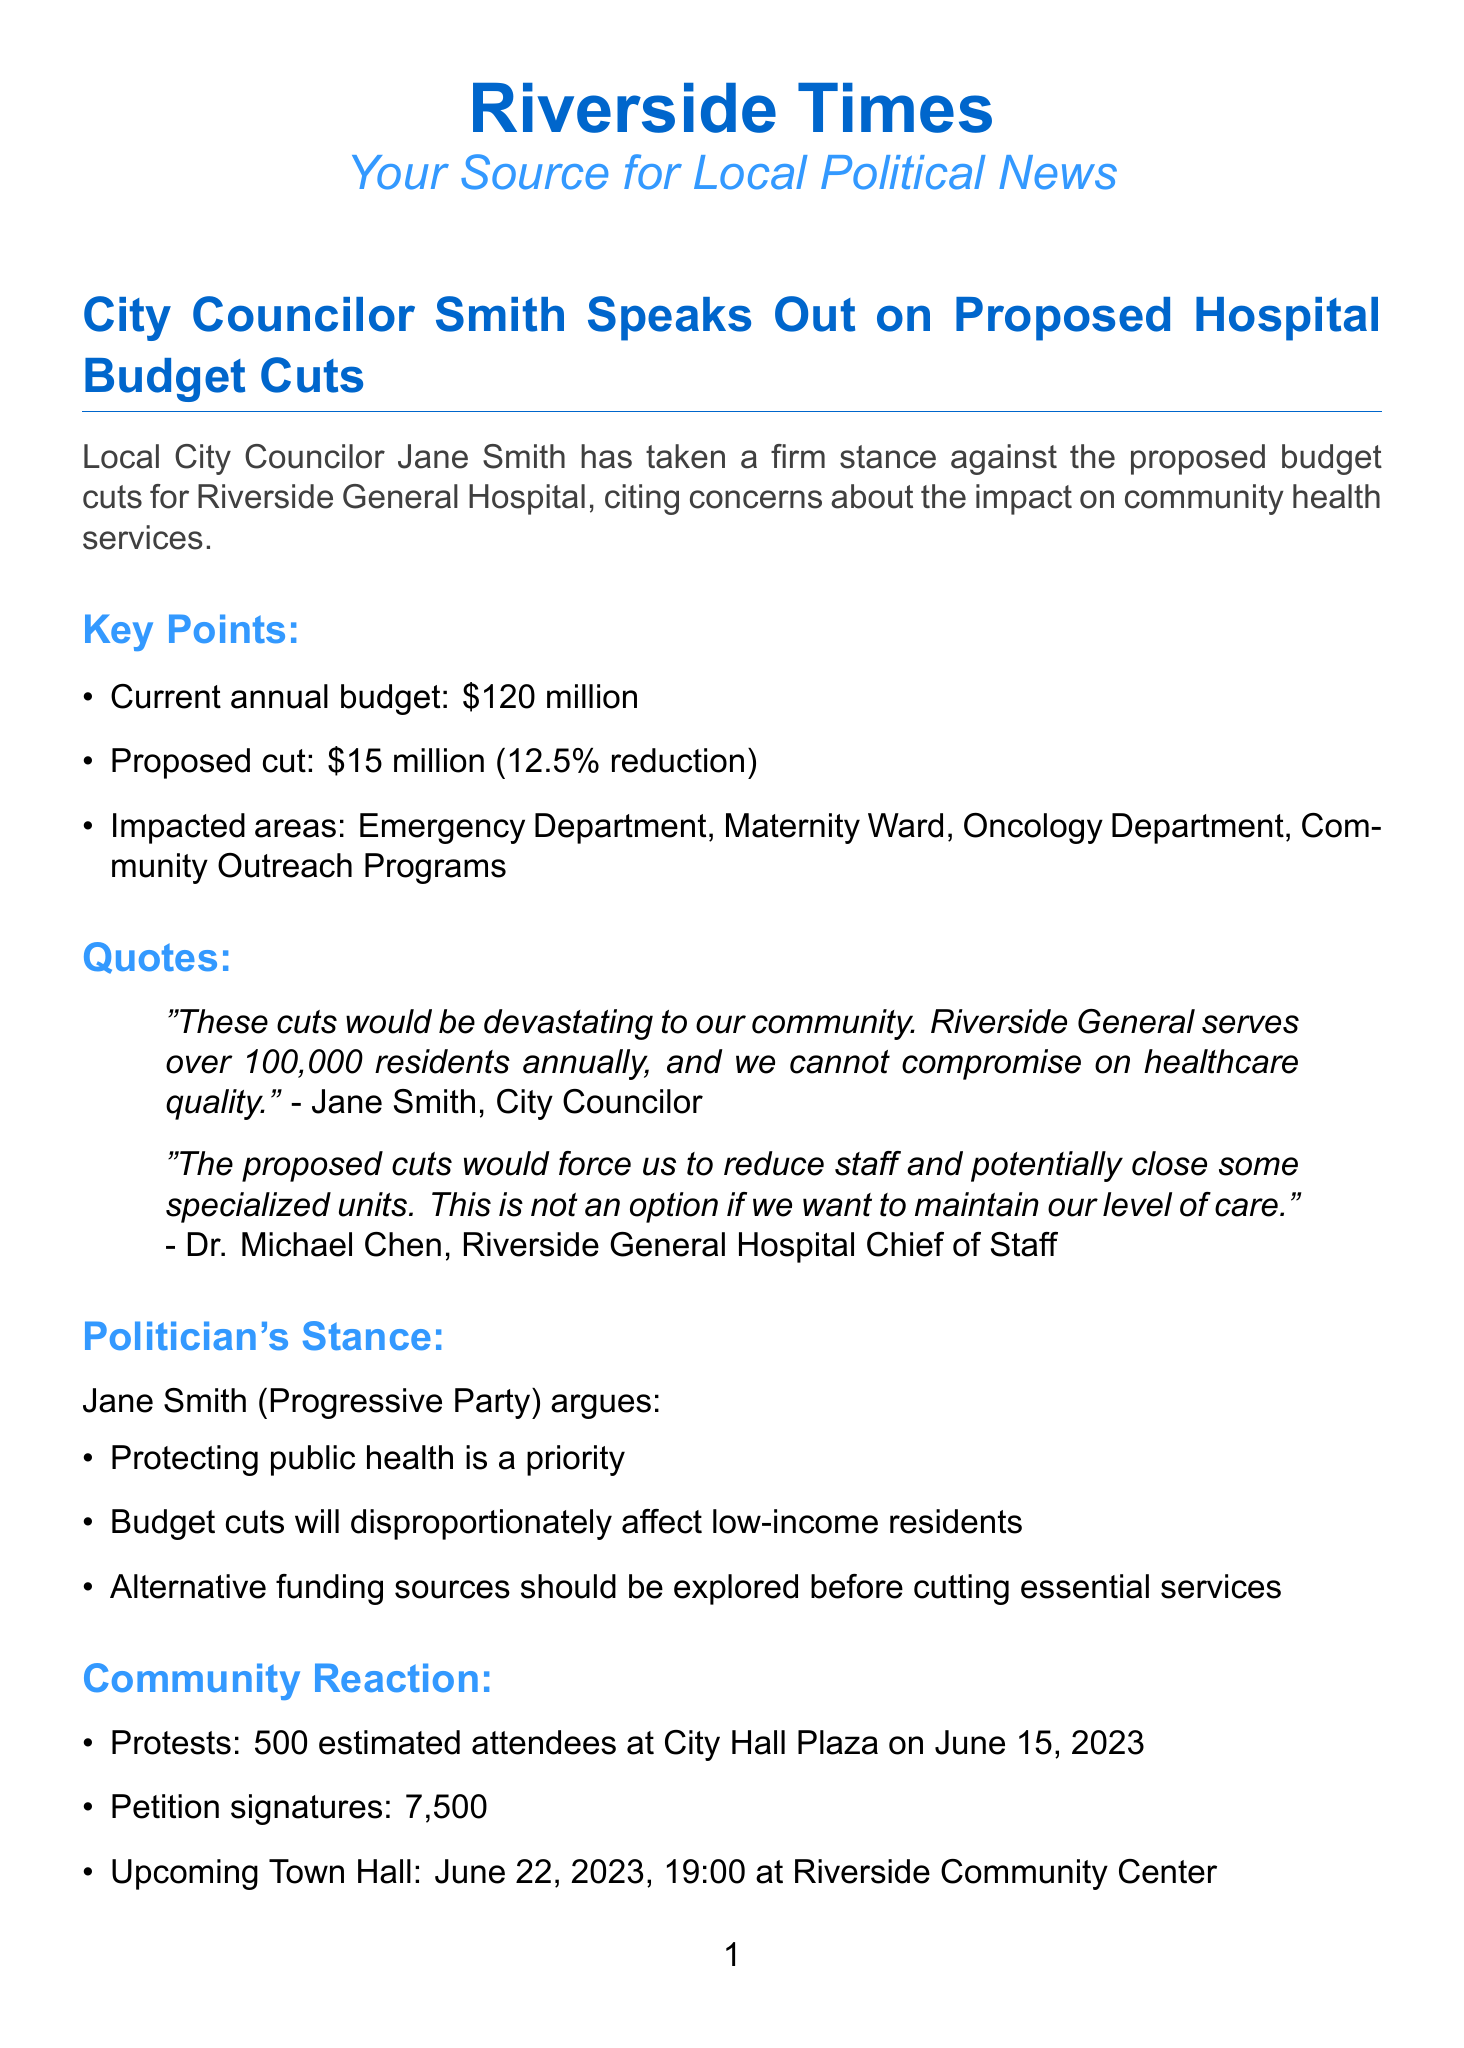What is the current annual budget for Riverside General Hospital? The document states that the current annual budget for Riverside General Hospital is $120 million.
Answer: $120 million How much is the proposed budget cut? According to the document, the proposed budget cut is $15 million.
Answer: $15 million What percentage reduction does the proposed cut represent? The document indicates that the proposed cut represents a 12.5% reduction in the budget.
Answer: 12.5% Which hospital service areas are impacted by the cuts? The impacted areas mentioned in the document include Emergency Department, Maternity Ward, Oncology Department, and Community Outreach Programs.
Answer: Emergency Department, Maternity Ward, Oncology Department, Community Outreach Programs What is Jane Smith's political party affiliation? The document specifies that Jane Smith is affiliated with the Progressive Party.
Answer: Progressive Party How many estimated attendees were present at the City Hall Plaza protest? The document mentions an estimated attendance of 500 at the protest held at City Hall Plaza.
Answer: 500 What alternative funding source does Jane Smith suggest should be explored? The document lists several alternative funding sources, one of which includes seeking additional state and federal grants.
Answer: Additional state and federal grants Who is Dr. Michael Chen? According to the document, Dr. Michael Chen is the Chief of Staff at Riverside General Hospital.
Answer: Chief of Staff When is the upcoming Town Hall meeting scheduled? The document states that the upcoming Town Hall meeting is scheduled for June 22, 2023, at 19:00.
Answer: June 22, 2023, at 19:00 